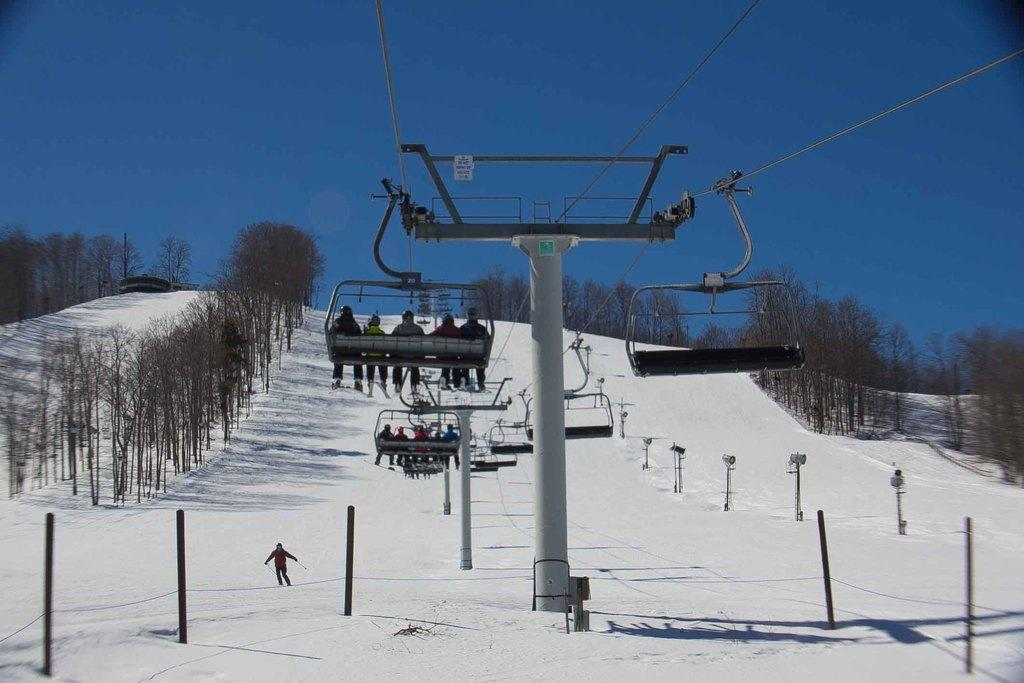What structures can be seen in the image? There are poles in the image. What mode of transportation is present in the image? Cable cars are present in the image. What connects the poles and cable cars? Cables are visible in the image. What type of natural environment is depicted in the image? There are trees in the image. Are there any people in the image? Yes, people are in the image. What is the weather like in the image? Snow is present in the image. What activity is a man engaged in within the image? A man is skiing in the image. What is visible at the top of the image? The sky is visible at the top of the image. What type of payment method is accepted for the cable car ride in the image? There is no information about payment methods in the image; it only shows cable cars, poles, cables, trees, people, snow, a skiing man, and the sky. How many steps are required to board the cable car in the image? There are no steps mentioned or depicted in the image; it only shows cable cars, poles, cables, trees, people, snow, a skiing man, and the sky. 